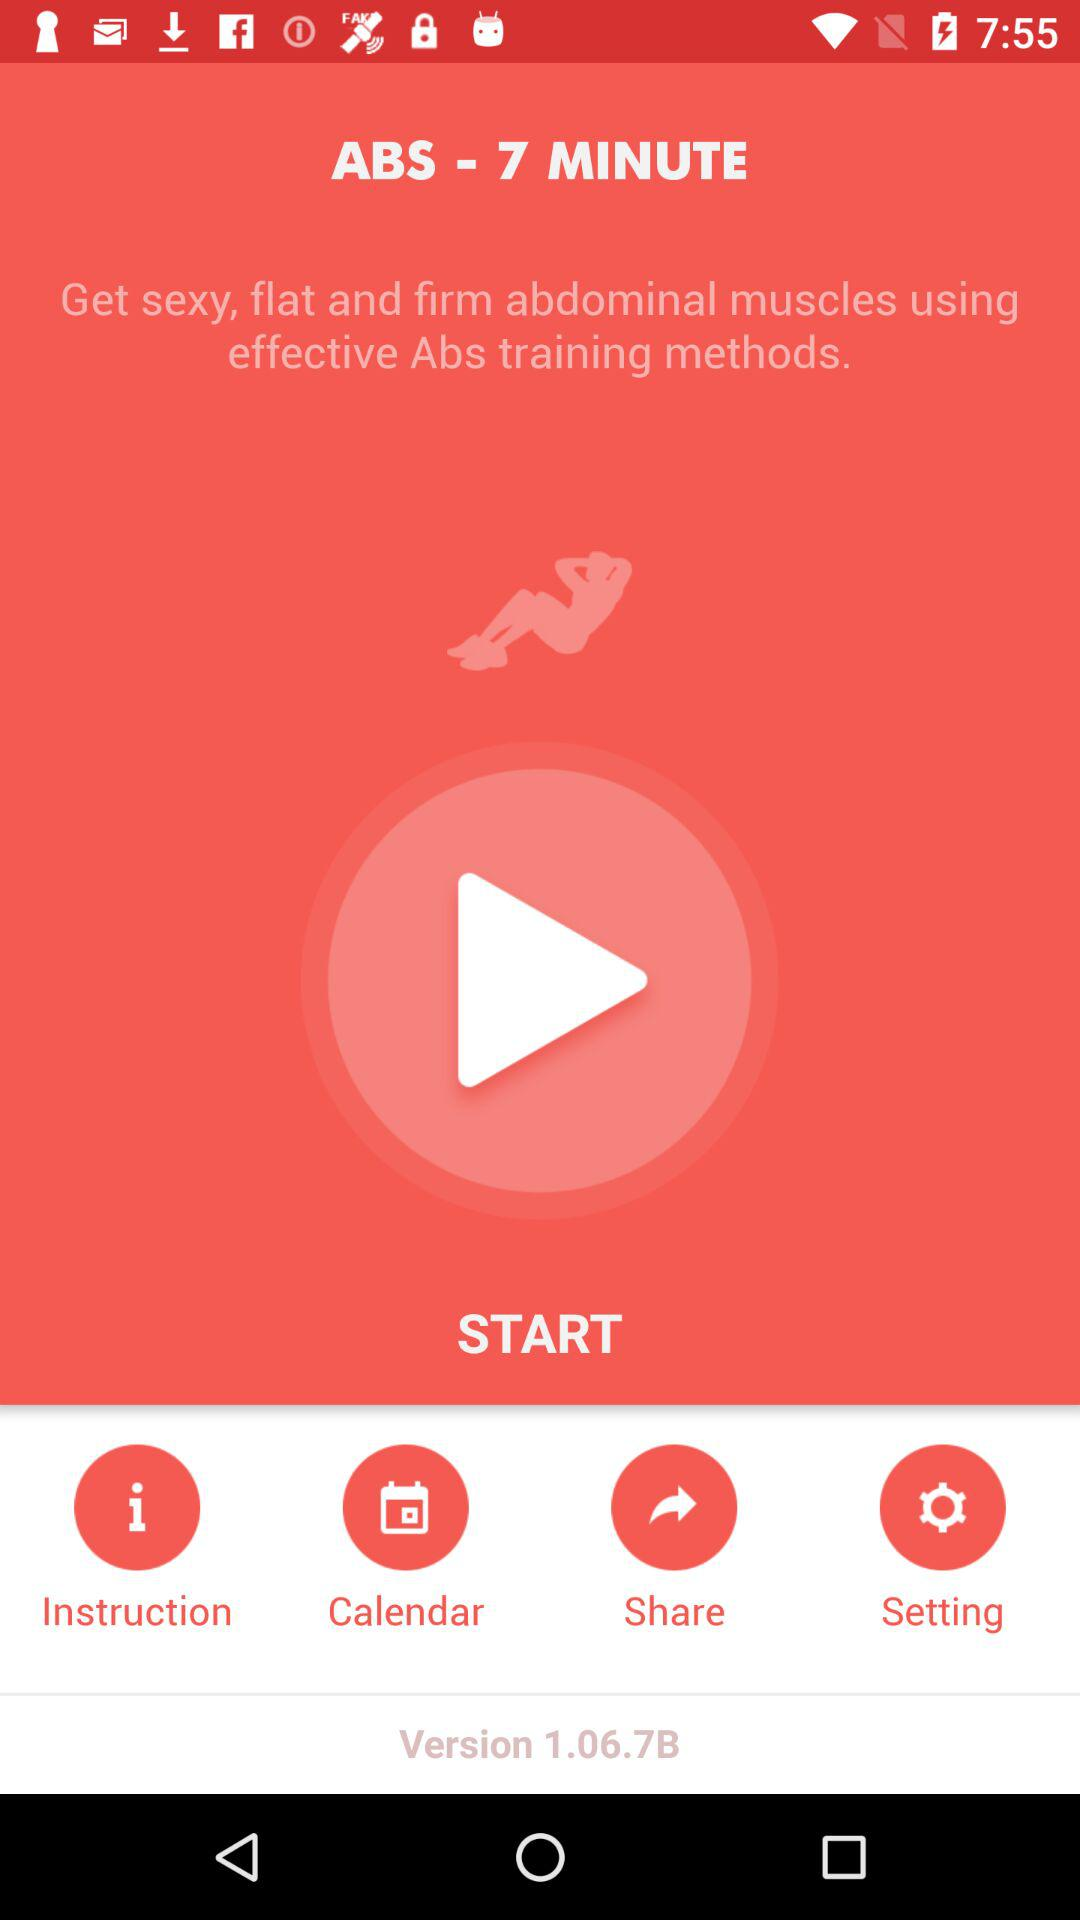What is the version? The version is 1.06.7B. 